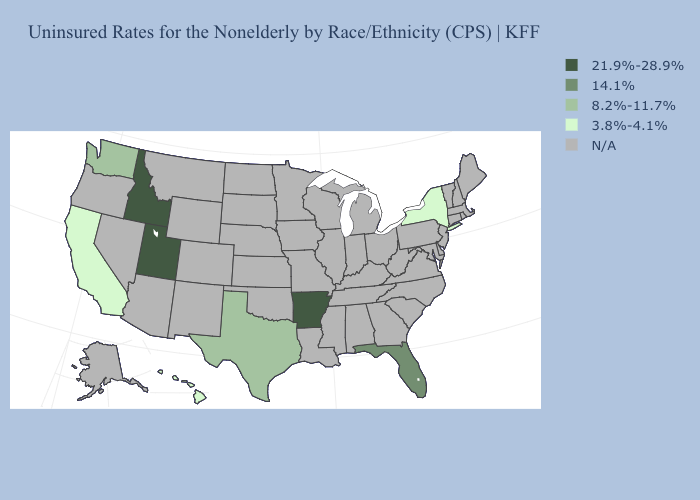What is the value of Massachusetts?
Answer briefly. N/A. Does Hawaii have the highest value in the USA?
Short answer required. No. Name the states that have a value in the range 8.2%-11.7%?
Give a very brief answer. Texas, Washington. What is the lowest value in the USA?
Answer briefly. 3.8%-4.1%. Name the states that have a value in the range N/A?
Give a very brief answer. Alabama, Alaska, Arizona, Colorado, Connecticut, Delaware, Georgia, Illinois, Indiana, Iowa, Kansas, Kentucky, Louisiana, Maine, Maryland, Massachusetts, Michigan, Minnesota, Mississippi, Missouri, Montana, Nebraska, Nevada, New Hampshire, New Jersey, New Mexico, North Carolina, North Dakota, Ohio, Oklahoma, Oregon, Pennsylvania, Rhode Island, South Carolina, South Dakota, Tennessee, Vermont, Virginia, West Virginia, Wisconsin, Wyoming. What is the highest value in states that border Wyoming?
Short answer required. 21.9%-28.9%. Name the states that have a value in the range 8.2%-11.7%?
Answer briefly. Texas, Washington. Name the states that have a value in the range 14.1%?
Keep it brief. Florida. What is the value of Nebraska?
Give a very brief answer. N/A. What is the value of South Dakota?
Quick response, please. N/A. Name the states that have a value in the range 14.1%?
Short answer required. Florida. Does Texas have the highest value in the South?
Write a very short answer. No. Name the states that have a value in the range 14.1%?
Quick response, please. Florida. Which states have the lowest value in the Northeast?
Short answer required. New York. 